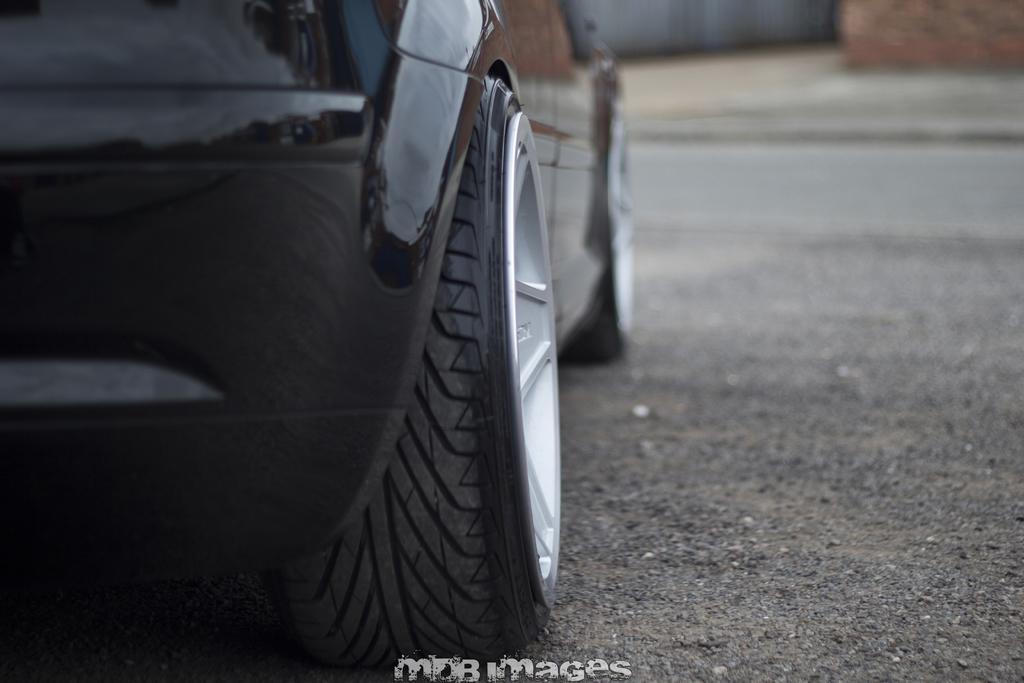What is the main subject of the image? There is a car in the image. Where is the car located? The car is on the road. Can you describe any additional features of the image? There is a watermark in the bottom of the image. What color is the car? The car is black in color. How would you describe the background of the image? The background of the image is blurred. How many oranges are being sold for profit in the image? There are no oranges or references to profit in the image; it features a black car on the road. 